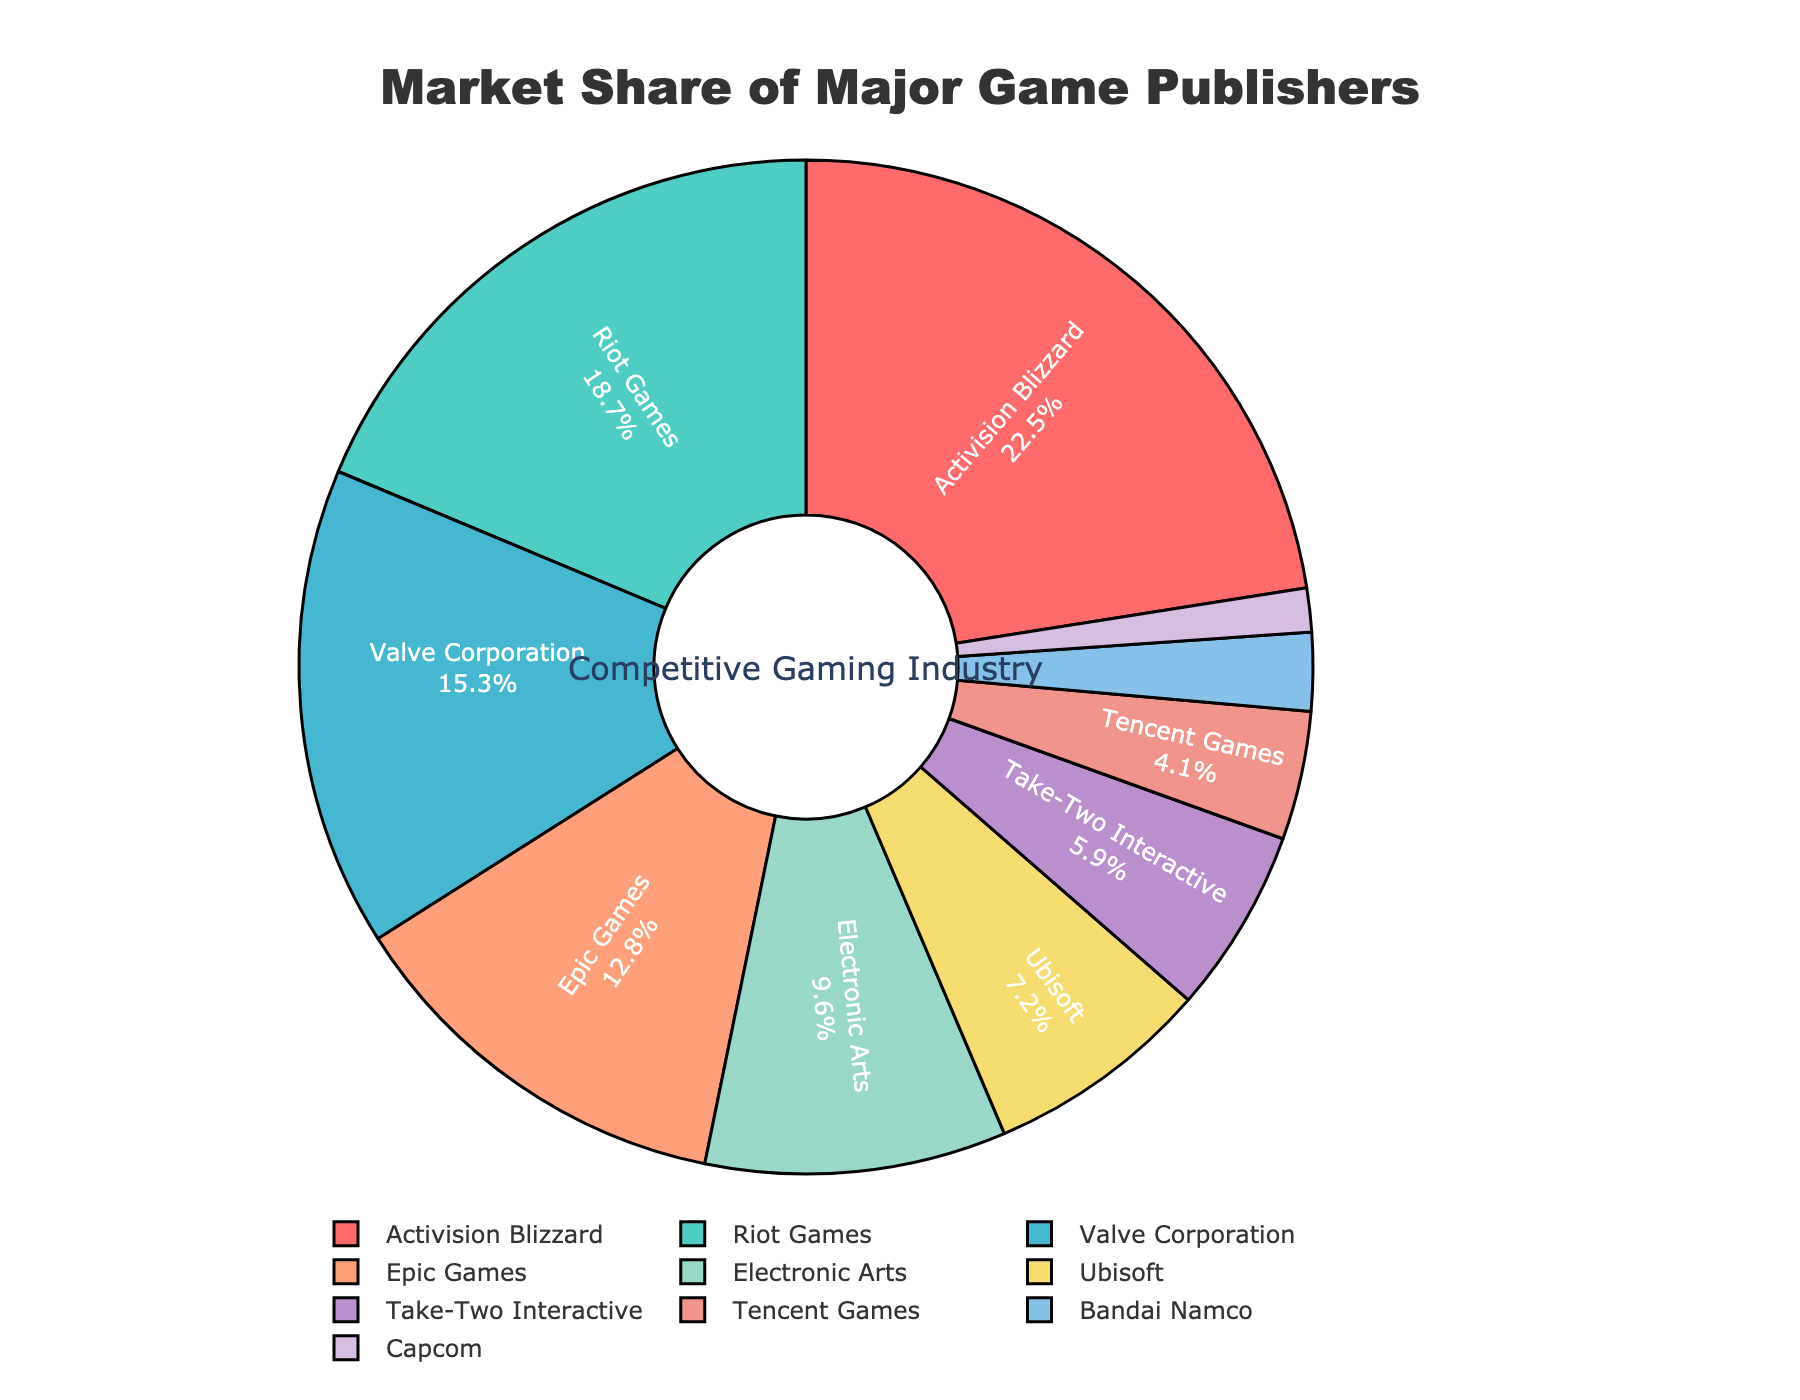Which company has the largest market share? By examining the pie chart, we can see that Activision Blizzard holds the largest slice of the pie chart, indicating the highest market share compared to other companies.
Answer: Activision Blizzard Which company has a market share smaller than 4%? By analyzing the sections of the pie chart, we observe that Tencent Games has a market share of 4.1%, just above the threshold, but Bandai Namco and Capcom have market shares of 2.5% and 1.4%, respectively, both below 4%.
Answer: Bandai Namco and Capcom What is the combined market share of Electronic Arts and Ubisoft? To find the combined market share, add the values for Electronic Arts and Ubisoft from the pie chart: 9.6% + 7.2% = 16.8%.
Answer: 16.8% Is Valve Corporation's market share greater than Epic Games'? By comparing the segments of the pie chart, we can see that Valve Corporation's market share is 15.3%, which is larger than Epic Games' market share of 12.8%.
Answer: Yes What's the difference in market share between Activision Blizzard and Riot Games? By finding the difference between Activision Blizzard's market share (22.5%) and Riot Games' market share (18.7%), we get 22.5% - 18.7% = 3.8%.
Answer: 3.8% How many companies have a market share greater than 10%? By referring to the pie chart, we identify that Activision Blizzard (22.5%), Riot Games (18.7%), Valve Corporation (15.3%), and Epic Games (12.8%) all have market shares greater than 10%. This totals to 4 companies.
Answer: 4 Which company is represented with a blue colored segment? Observing the color palette used in the pie chart, the blue segment corresponds to Valve Corporation.
Answer: Valve Corporation What's the sum of market shares of the bottom three companies with the smallest market share? From the chart, the bottom three companies are Bandai Namco (2.5%), Capcom (1.4%), and Tencent Games (4.1%). Adding these gives 2.5% + 1.4% + 4.1% = 8%.
Answer: 8% What's the average market share of all companies listed in the chart? To calculate the average market share, sum up all the market shares and divide by the number of companies. (22.5 + 18.7 + 15.3 + 12.8 + 9.6 + 7.2 + 5.9 + 4.1 + 2.5 + 1.4) = 100. Then, 100 / 10 (number of companies) = 10%.
Answer: 10% Is the total market share of Epic Games and Ubisoft larger than Activision Blizzard's market share? Adding the market share of Epic Games (12.8%) and Ubisoft (7.2%) gives 12.8% + 7.2% = 20%. Activision Blizzard has a market share of 22.5%. Therefore, 20% is not larger than 22.5%.
Answer: No 